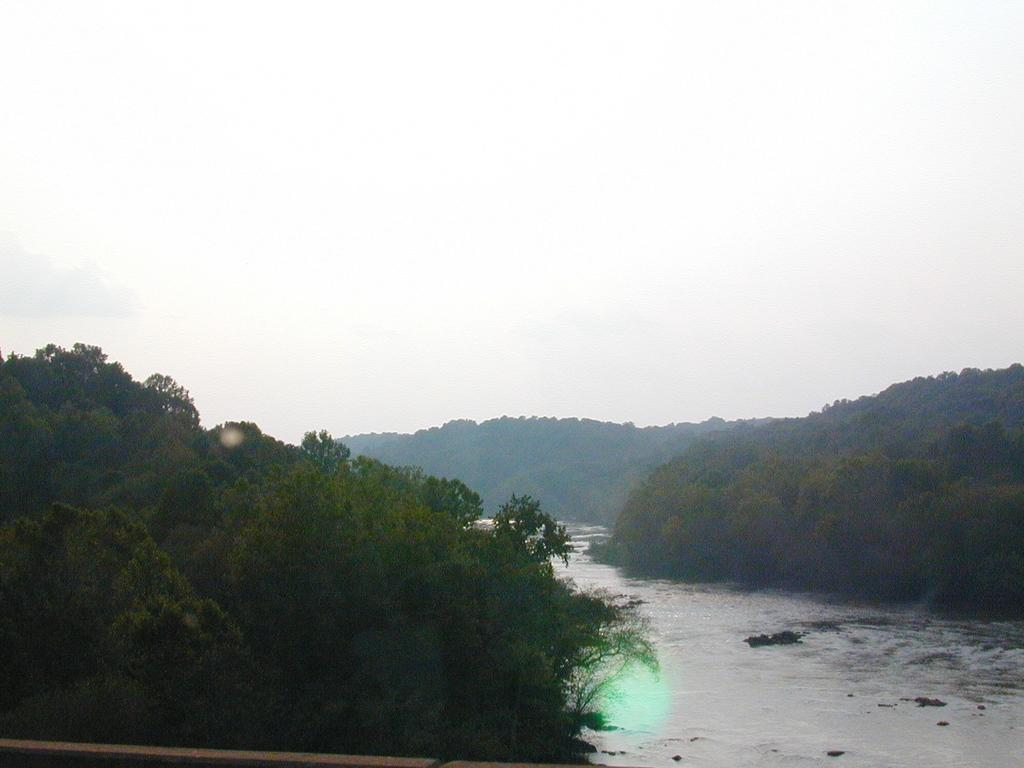What type of natural feature is present in the image? There is a river in the image. What can be seen on the sides of the river? There are trees on the sides of the river. What is visible in the background of the image? The sky is visible in the background of the image. What type of oatmeal is being cooked in the image? There is no oatmeal present in the image; it features a river with trees on its sides and a visible sky in the background. 